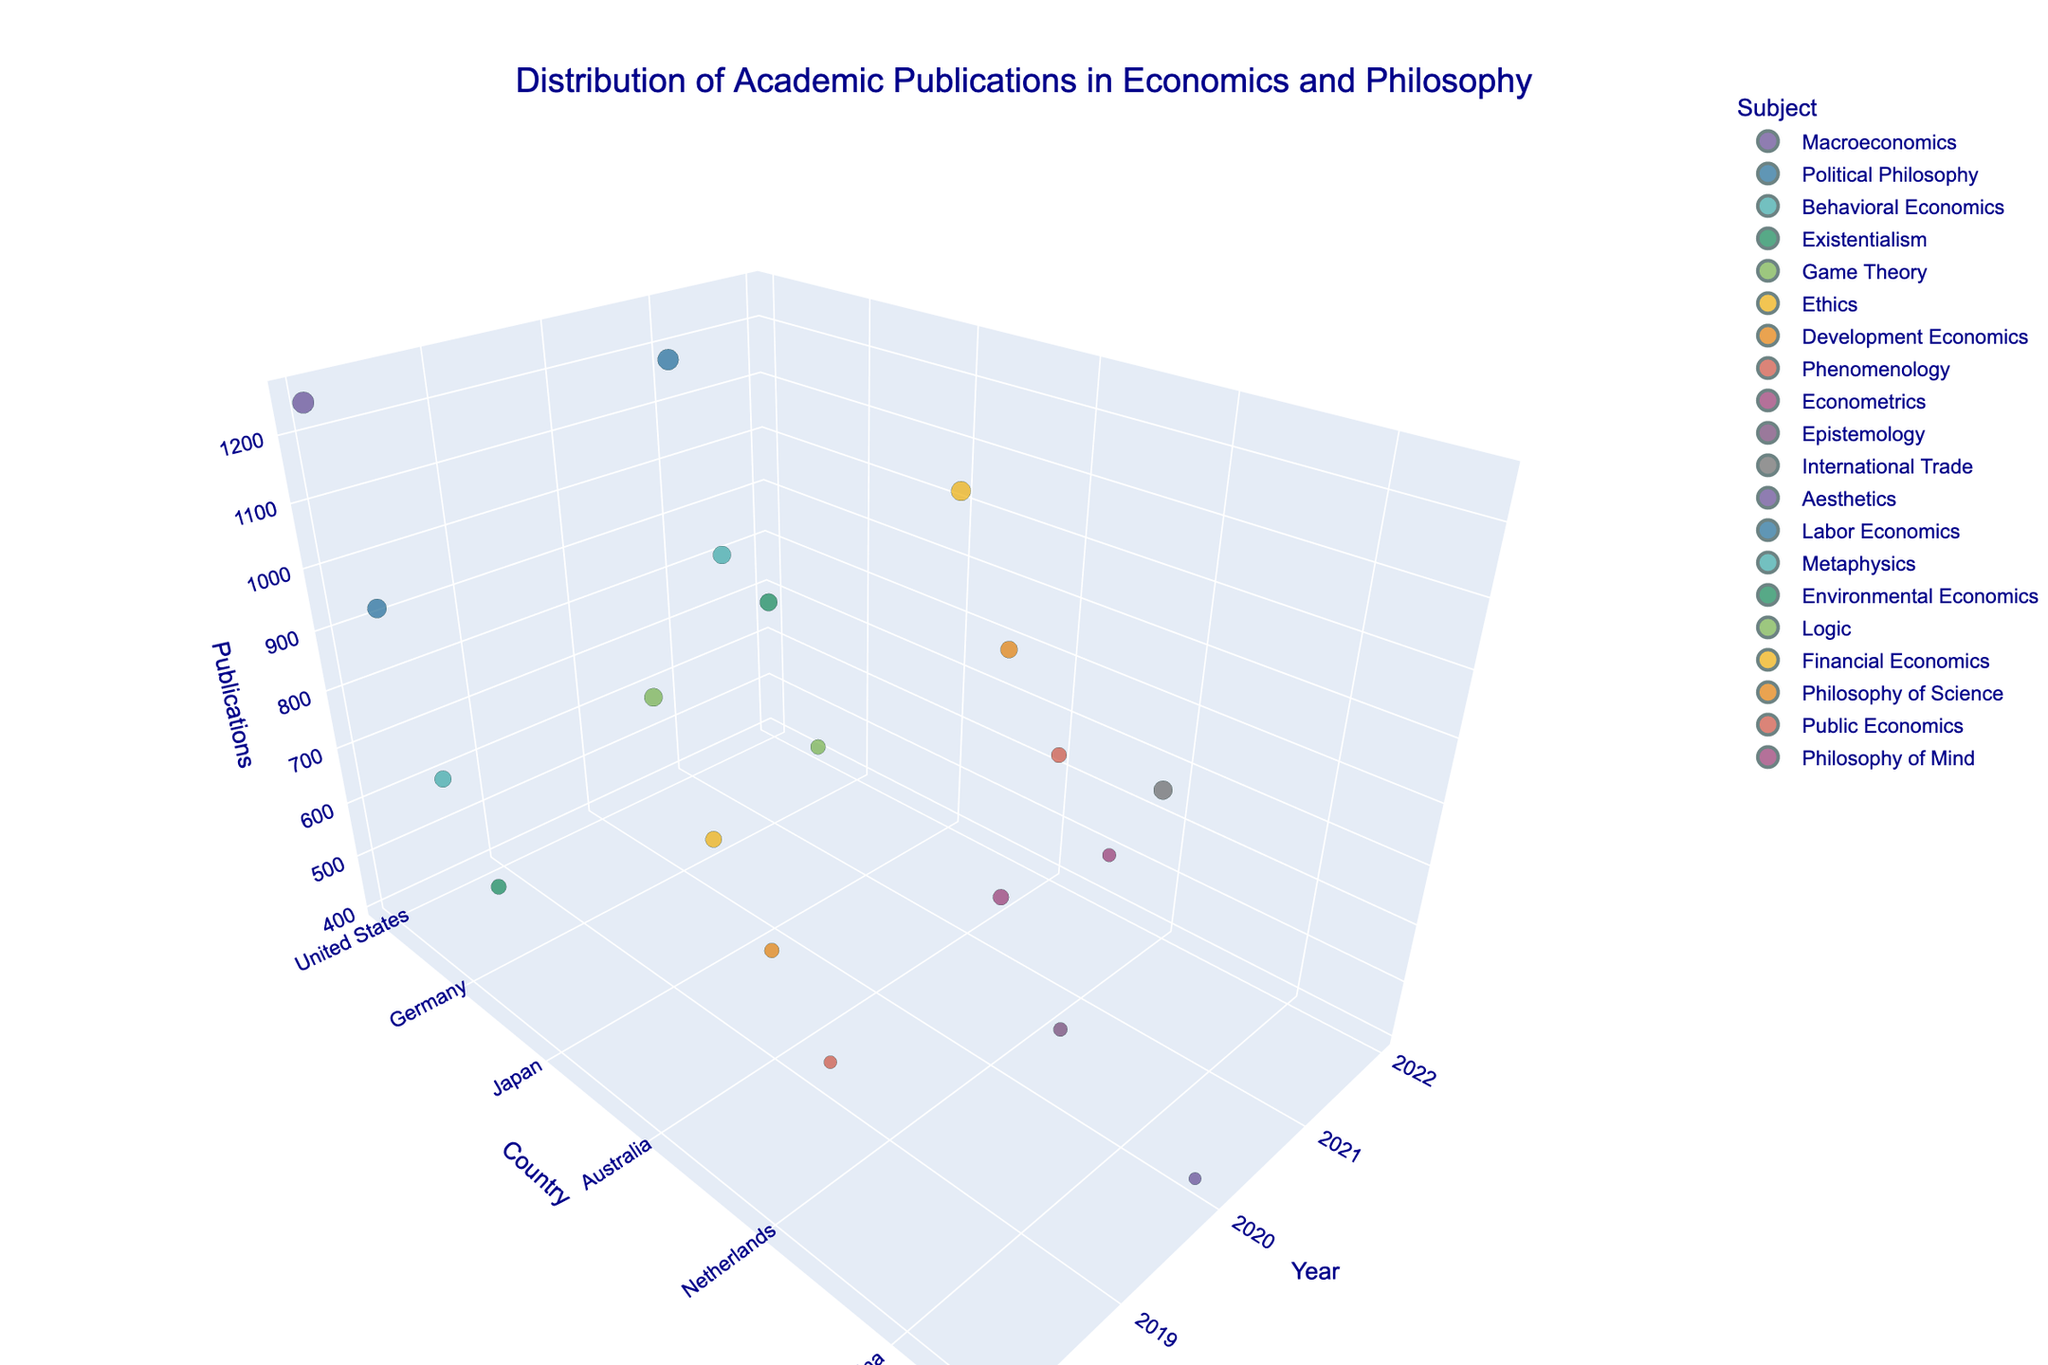What is the title of the 3D plot? The title of the plot can be found at the top and it states the main theme or topic being visualized in the figure.
Answer: Distribution of Academic Publications in Economics and Philosophy Which country has the highest number of publications in 2018? Locate the year 2018 on the x-axis and observe the data points associated with each country, then identify the country with the highest z-value (Publications).
Answer: United States How many publications were there for 'Philosophy of Science' in 2022? Locate the year 2022 on the x-axis, find the data points colored based on the subject 'Philosophy of Science', and then read the z-value (Publications).
Answer: 780 Is the number of publications in 'Public Economics' higher or lower than 'Financial Economics' in 2022? Compare the z-values (Publications) for data points corresponding to 'Public Economics' and 'Financial Economics' for the year 2022 on the x-axis.
Answer: Lower Which subject area had the highest number of publications in 2021 in the United States? For the year 2021 on the x-axis and the country 'United States' on the y-axis, identify the data point with the highest z-value (Publications) and note its subject.
Answer: Labor Economics What is the average number of publications across all countries in 2018? Sum the number of publications for all countries in 2018 and divide by the number of countries reported for that year.
Answer: 900 Compare the number of publications in 'Behavioral Economics' and 'Political Philosophy' in 2018. Which is higher? Identify the publications for 'Behavioral Economics' and 'Political Philosophy' in 2018 on the z-axis, then compare the two values.
Answer: Political Philosophy What is the trend of publications in the United Kingdom from 2018 to 2021 in the given data? Observe the data points representing the United Kingdom across the years 2018 to 2021 and note the trend in the height of the data points (Publications).
Answer: Decreasing How does the number of publications in 'Existentialism' in 2018 compare with 'Phenomenology' in 2019? Find the z-values (Publications) for 'Existentialism' in 2018 and 'Phenomenology' in 2019 and compare them.
Answer: Higher in 2018 Which year had the highest number of publications for 'International Trade' and what is the value? Locate the subject 'International Trade' on the y-axis across different years and identify the year with the highest publication count on the z-axis.
Answer: 2020, 950 